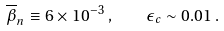Convert formula to latex. <formula><loc_0><loc_0><loc_500><loc_500>\overline { \beta } _ { n } \equiv 6 \times 1 0 ^ { - 3 } \, , \quad \epsilon _ { c } \sim 0 . 0 1 \, .</formula> 